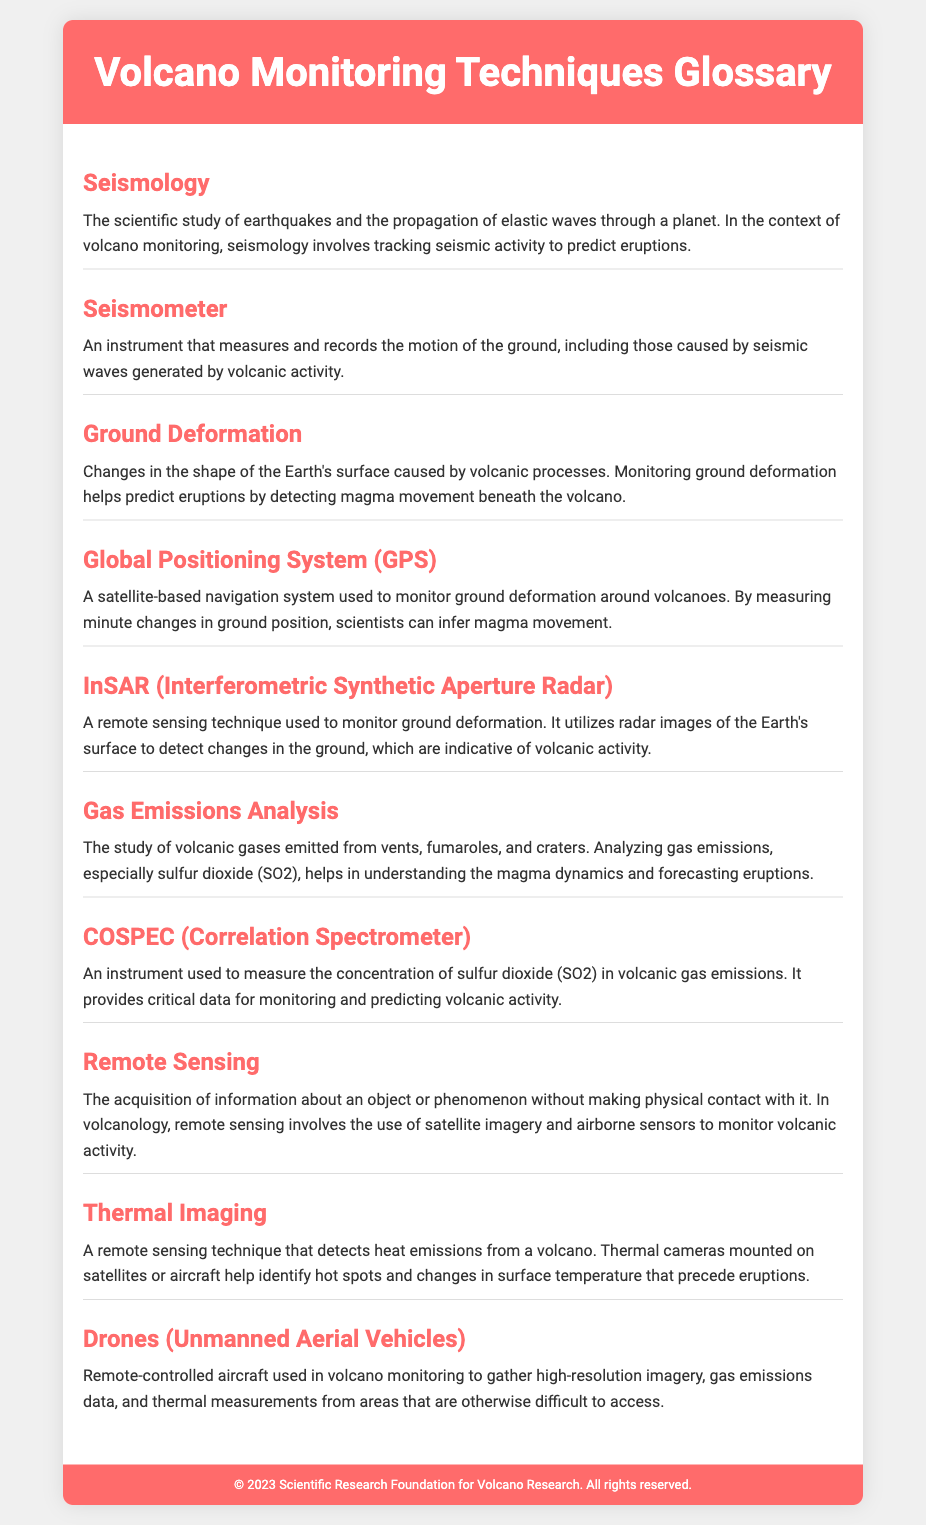what is the scientific study of earthquakes called? This term refers to the scientific field that focuses on earthquakes and the propagation of elastic waves, which is crucial for monitoring volcanic activity.
Answer: Seismology what does InSAR stand for? The abbreviation represents a specific remote sensing technique used for monitoring ground deformation related to volcanic activity.
Answer: Interferometric Synthetic Aperture Radar which instrument measures sulfur dioxide concentration in volcanic gases? This instrument is specifically designed for monitoring gas emissions, particularly focusing on analyzing the concentration of sulfur dioxide.
Answer: COSPEC (Correlation Spectrometer) what do drones collect in volcano monitoring? Drones are utilized to gather various types of data in volcano monitoring, including imagery and gas emissions data in hard-to-access areas.
Answer: High-resolution imagery, gas emissions data, thermal measurements how does GPS contribute to volcanic monitoring? This technology plays a role in assessing ground deformation around volcanoes, significant for understanding magma movement.
Answer: Monitoring ground deformation what is the purpose of gas emissions analysis in volcanology? This analysis focuses on the study of volcanic gases to understand magma dynamics and predict eruptions.
Answer: Understanding magma dynamics and forecasting eruptions what technique is used to detect heat emissions from a volcano? This remote sensing method specifically identifies changes in temperature at volcanic sites, crucial for predicting activity.
Answer: Thermal Imaging what type of instrument is a seismometer? This instrument is categorized based on its function of measuring and recording ground motion, especially regarding seismic activities.
Answer: Measuring and recording ground motion 